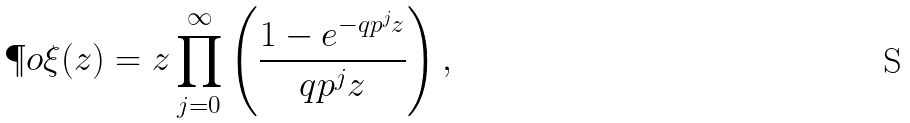<formula> <loc_0><loc_0><loc_500><loc_500>\P o { \xi } ( z ) = z \prod _ { j = 0 } ^ { \infty } \left ( \frac { 1 - e ^ { - q p ^ { j } z } } { q p ^ { j } z } \right ) ,</formula> 